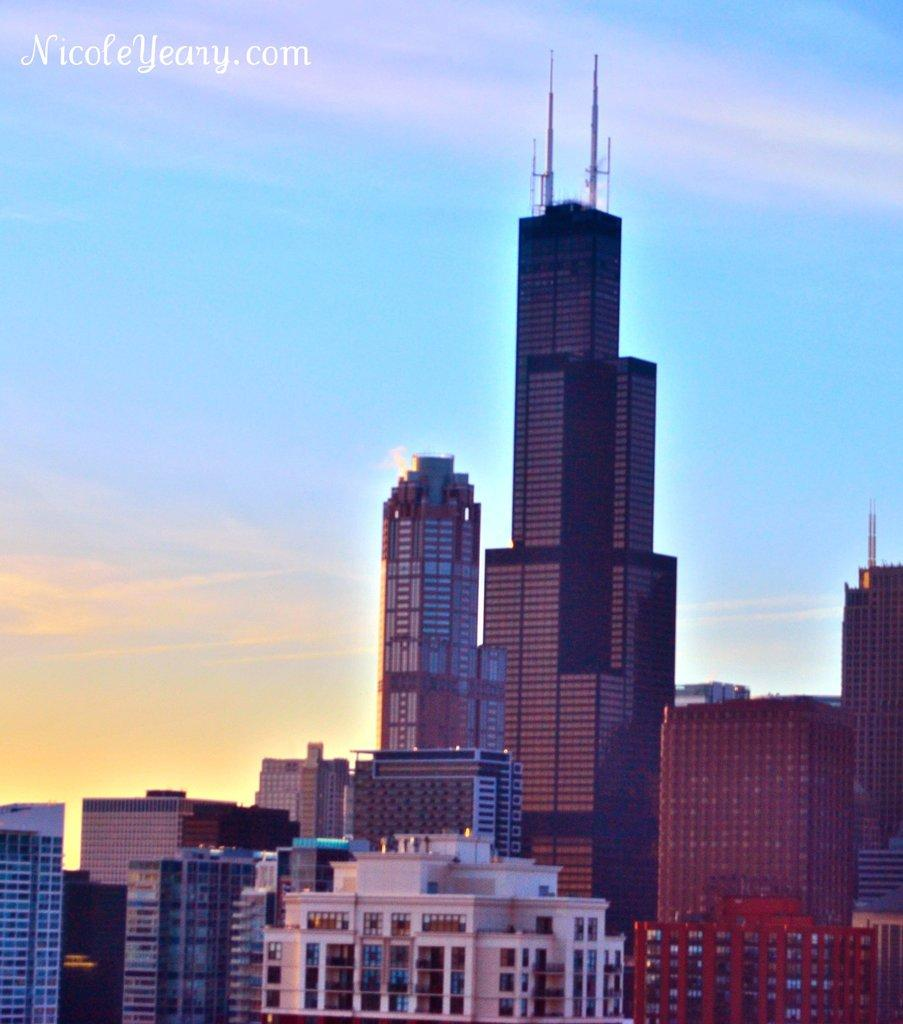What type of structures can be seen in the image? There are buildings in the image. Can you describe any differences between the buildings? One building is longer than the others. What is the condition of the sky in the image? The sky is clear in the image. How many balloons are tied to the longest building in the image? There are no balloons present in the image. What type of drainage system is visible in the image? There is no drainage system visible in the image. 